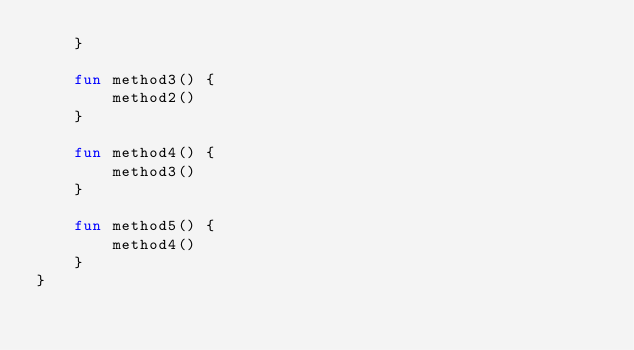Convert code to text. <code><loc_0><loc_0><loc_500><loc_500><_Kotlin_>    }

    fun method3() {
        method2()
    }

    fun method4() {
        method3()
    }

    fun method5() {
        method4()
    }
}
</code> 